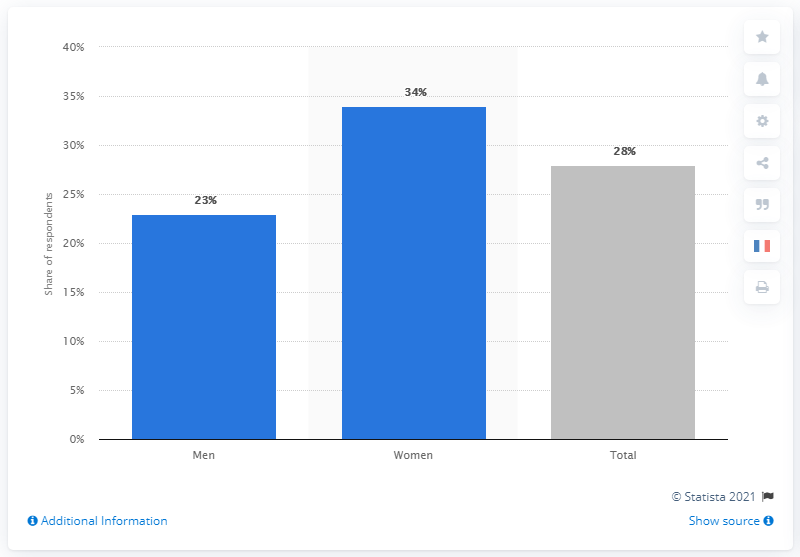What was the percentage of men worried about Coronavirus?
 23 